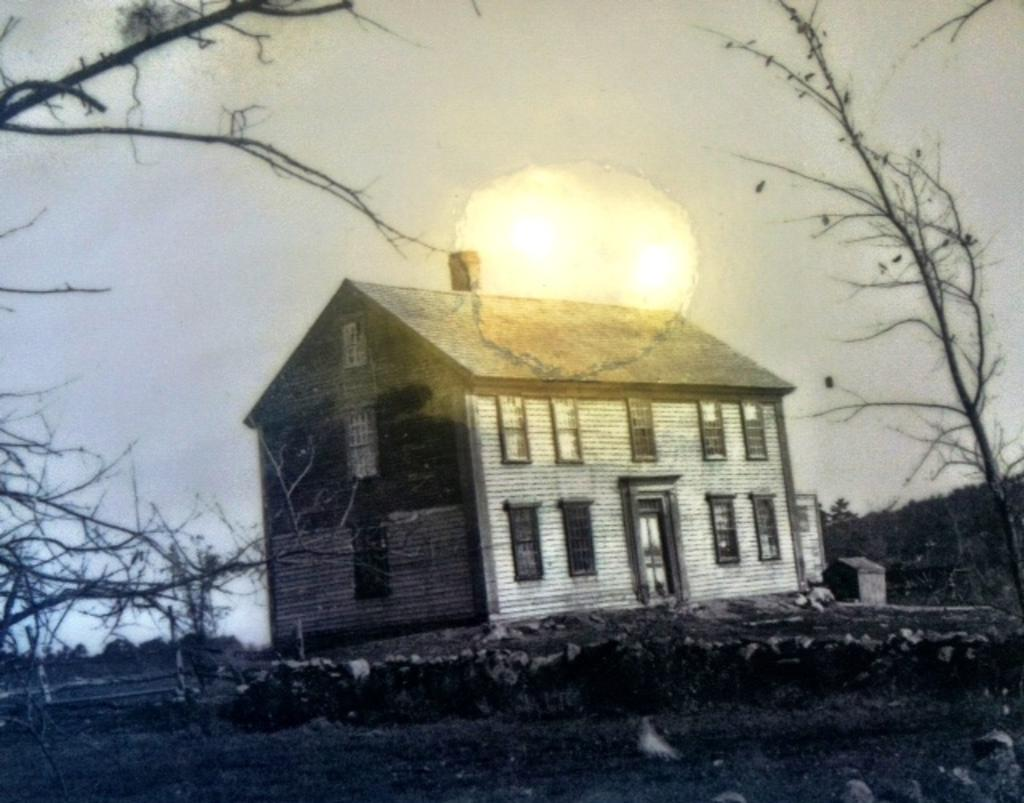What type of structure is present in the image? There is a house in the image. What feature of the house can be seen in the image? The house has windows. What type of natural vegetation is visible in the image? There are trees visible in the image. What type of minute agreement was reached between the trees in the image? There is no indication in the image of any agreement, minute or otherwise, between the trees. 